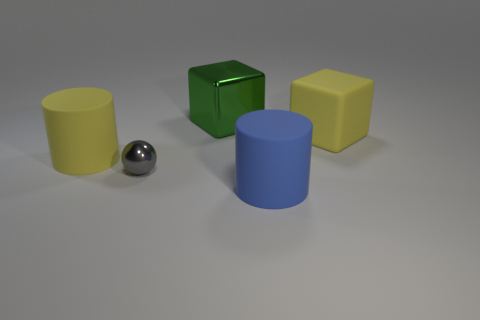Is there anything else that is the same size as the rubber cube?
Keep it short and to the point. Yes. How many small gray metallic spheres are there?
Offer a very short reply. 1. How many big matte cylinders are in front of the metal ball and behind the tiny object?
Make the answer very short. 0. Is there any other thing that has the same shape as the gray object?
Ensure brevity in your answer.  No. There is a big rubber block; is it the same color as the big cylinder that is behind the tiny sphere?
Provide a short and direct response. Yes. The shiny thing that is in front of the large metal thing has what shape?
Give a very brief answer. Sphere. How many other objects are the same material as the yellow cylinder?
Provide a succinct answer. 2. What is the gray thing made of?
Provide a short and direct response. Metal. What number of large objects are either shiny things or balls?
Offer a very short reply. 1. There is a metal cube; how many blocks are right of it?
Provide a short and direct response. 1. 